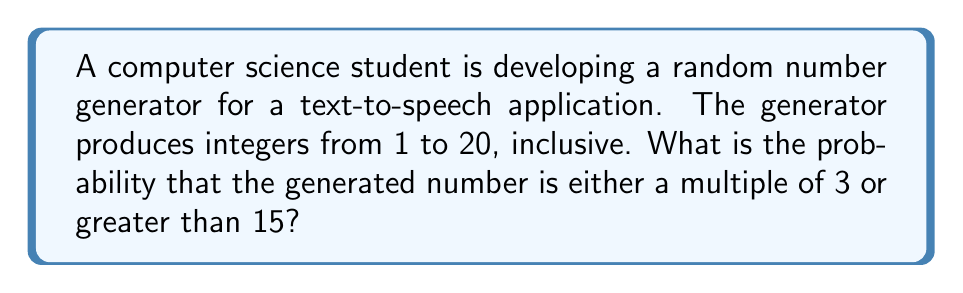Solve this math problem. Let's approach this step-by-step:

1) First, let's identify the numbers that satisfy our conditions:
   - Multiples of 3: 3, 6, 9, 12, 15, 18
   - Numbers greater than 15: 16, 17, 18, 19, 20

2) Now, let's count these numbers, being careful not to double-count:
   3, 6, 9, 12, 15, 16, 17, 18, 19, 20

3) We can see that there are 10 numbers that satisfy our conditions.

4) The total number of possible outcomes is 20 (integers from 1 to 20, inclusive).

5) The probability is calculated by dividing the number of favorable outcomes by the total number of possible outcomes:

   $$P(\text{multiple of 3 or > 15}) = \frac{\text{favorable outcomes}}{\text{total outcomes}} = \frac{10}{20}$$

6) This fraction can be simplified:

   $$\frac{10}{20} = \frac{1}{2}$$

Therefore, the probability is $\frac{1}{2}$ or 0.5 or 50%.
Answer: $\frac{1}{2}$ 